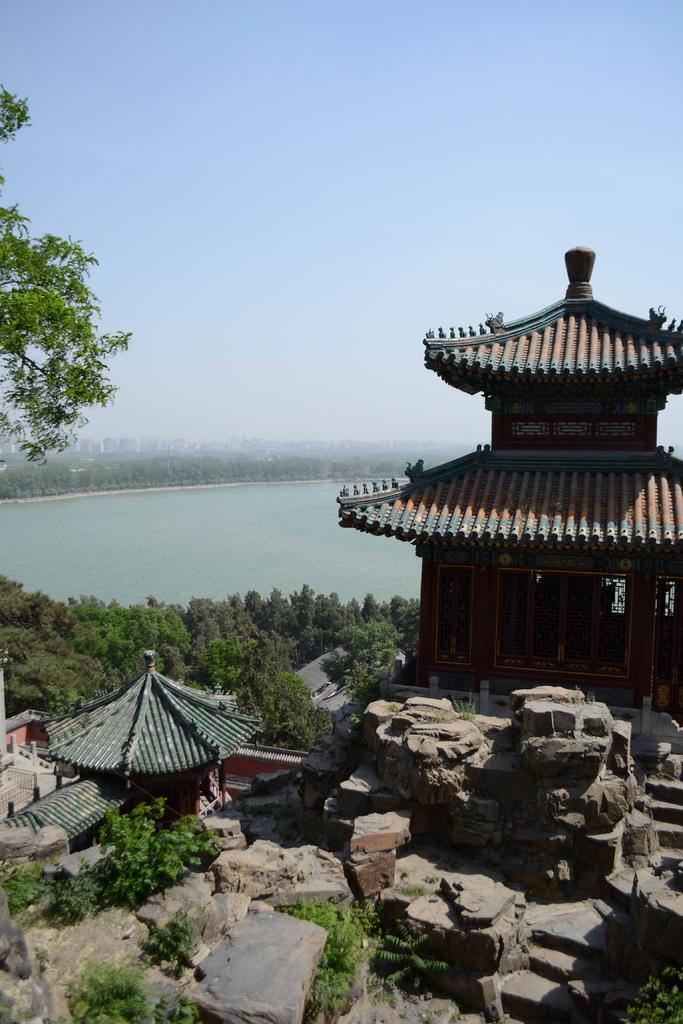What type of structures can be seen in the image? There are buildings in the image. What natural elements are present in the image? There are rocks, trees, and water visible in the image. What can be seen in the background of the image? The sky is visible in the background of the image. Can you tell me which direction the girl is facing in the image? There is no girl present in the image. Are there any fairies visible in the image? There are no fairies present in the image. 